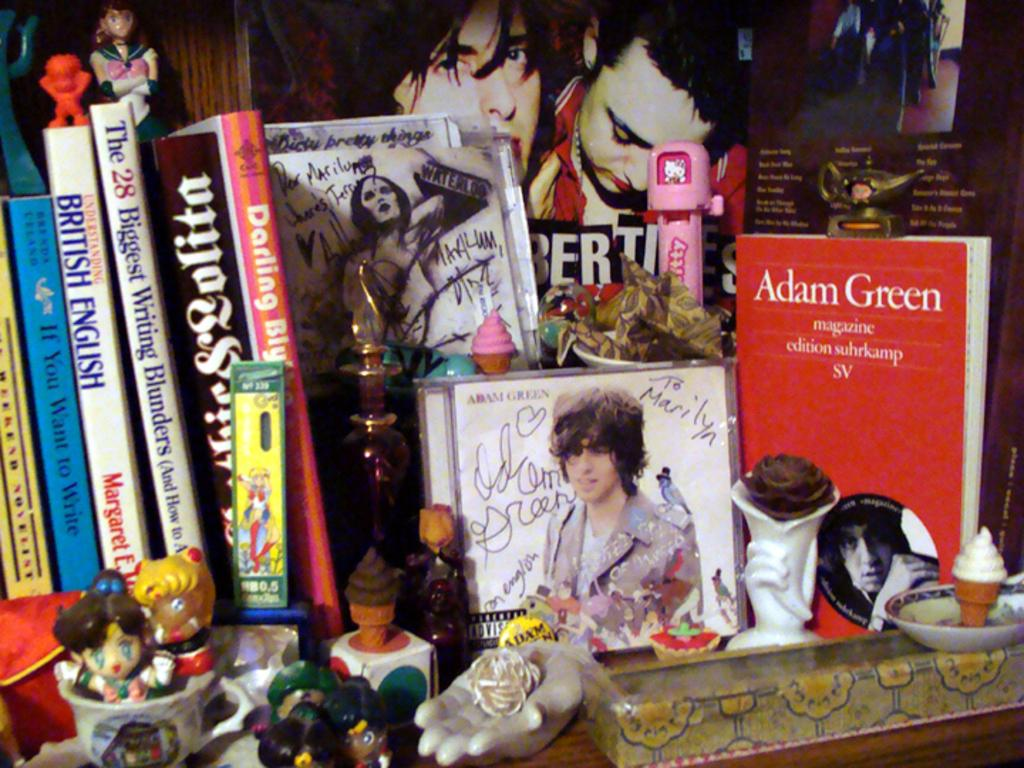<image>
Write a terse but informative summary of the picture. A group of CDs and books next to some ornaments, one of the books says Adam Green on it. 